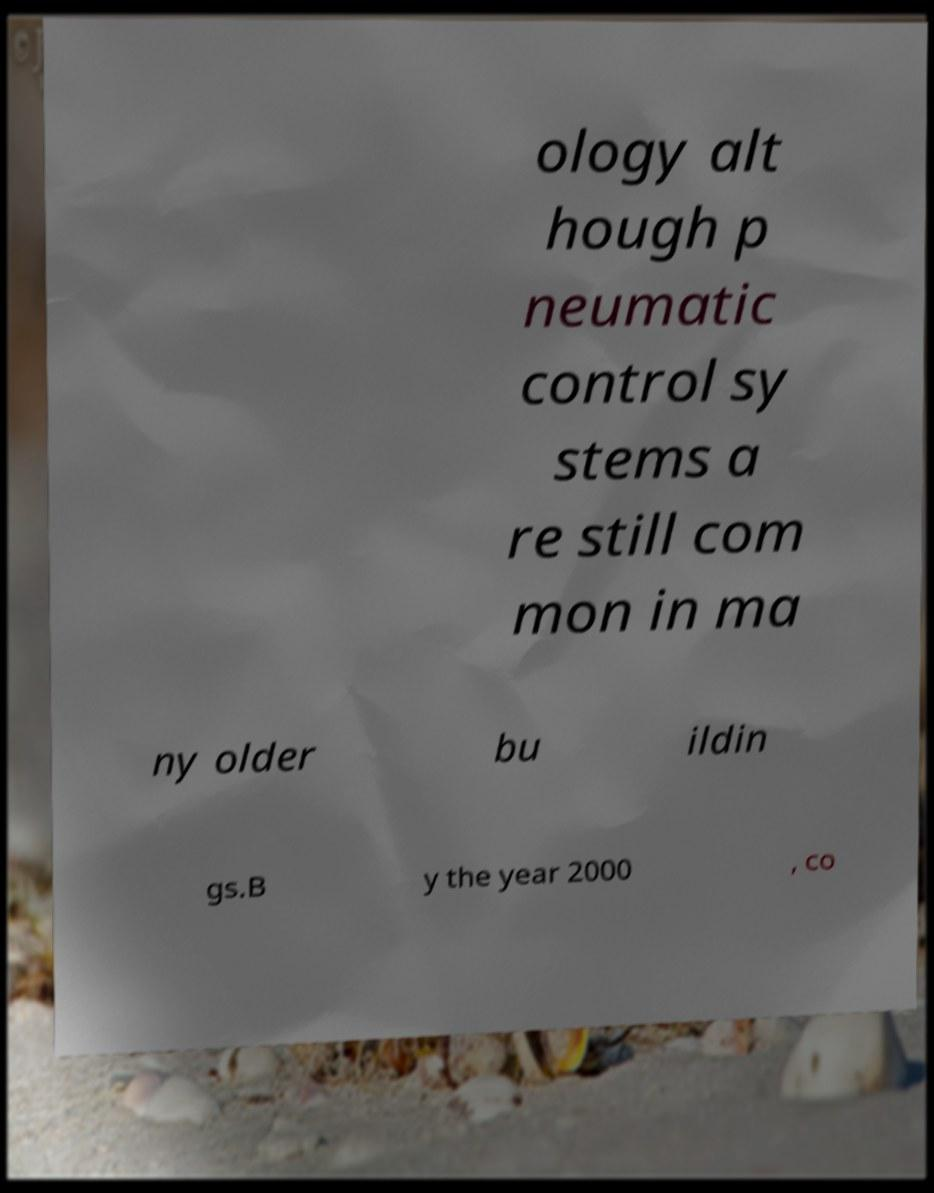Could you assist in decoding the text presented in this image and type it out clearly? ology alt hough p neumatic control sy stems a re still com mon in ma ny older bu ildin gs.B y the year 2000 , co 